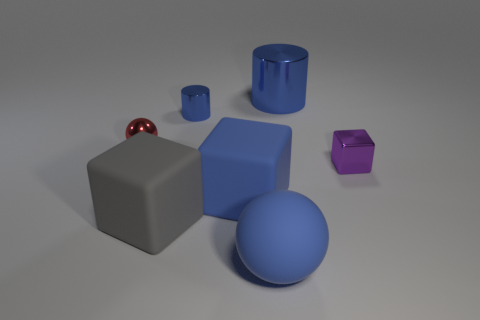What number of other things are there of the same material as the small red thing
Your response must be concise. 3. What number of objects are either blue metal cylinders that are on the left side of the blue matte ball or tiny blue rubber spheres?
Your answer should be compact. 1. Are there more blue metallic things than big blue things?
Make the answer very short. No. Are there any green matte cubes of the same size as the gray rubber block?
Offer a terse response. No. How many things are blue objects in front of the purple cube or cubes that are to the right of the large gray rubber thing?
Offer a very short reply. 3. What color is the metallic object that is to the left of the blue metallic thing on the left side of the big shiny cylinder?
Provide a short and direct response. Red. There is a small ball that is made of the same material as the tiny cylinder; what is its color?
Your response must be concise. Red. How many large rubber things have the same color as the matte sphere?
Provide a succinct answer. 1. What number of things are either large matte objects or large blue shiny balls?
Offer a very short reply. 3. What shape is the gray thing that is the same size as the blue ball?
Offer a terse response. Cube. 